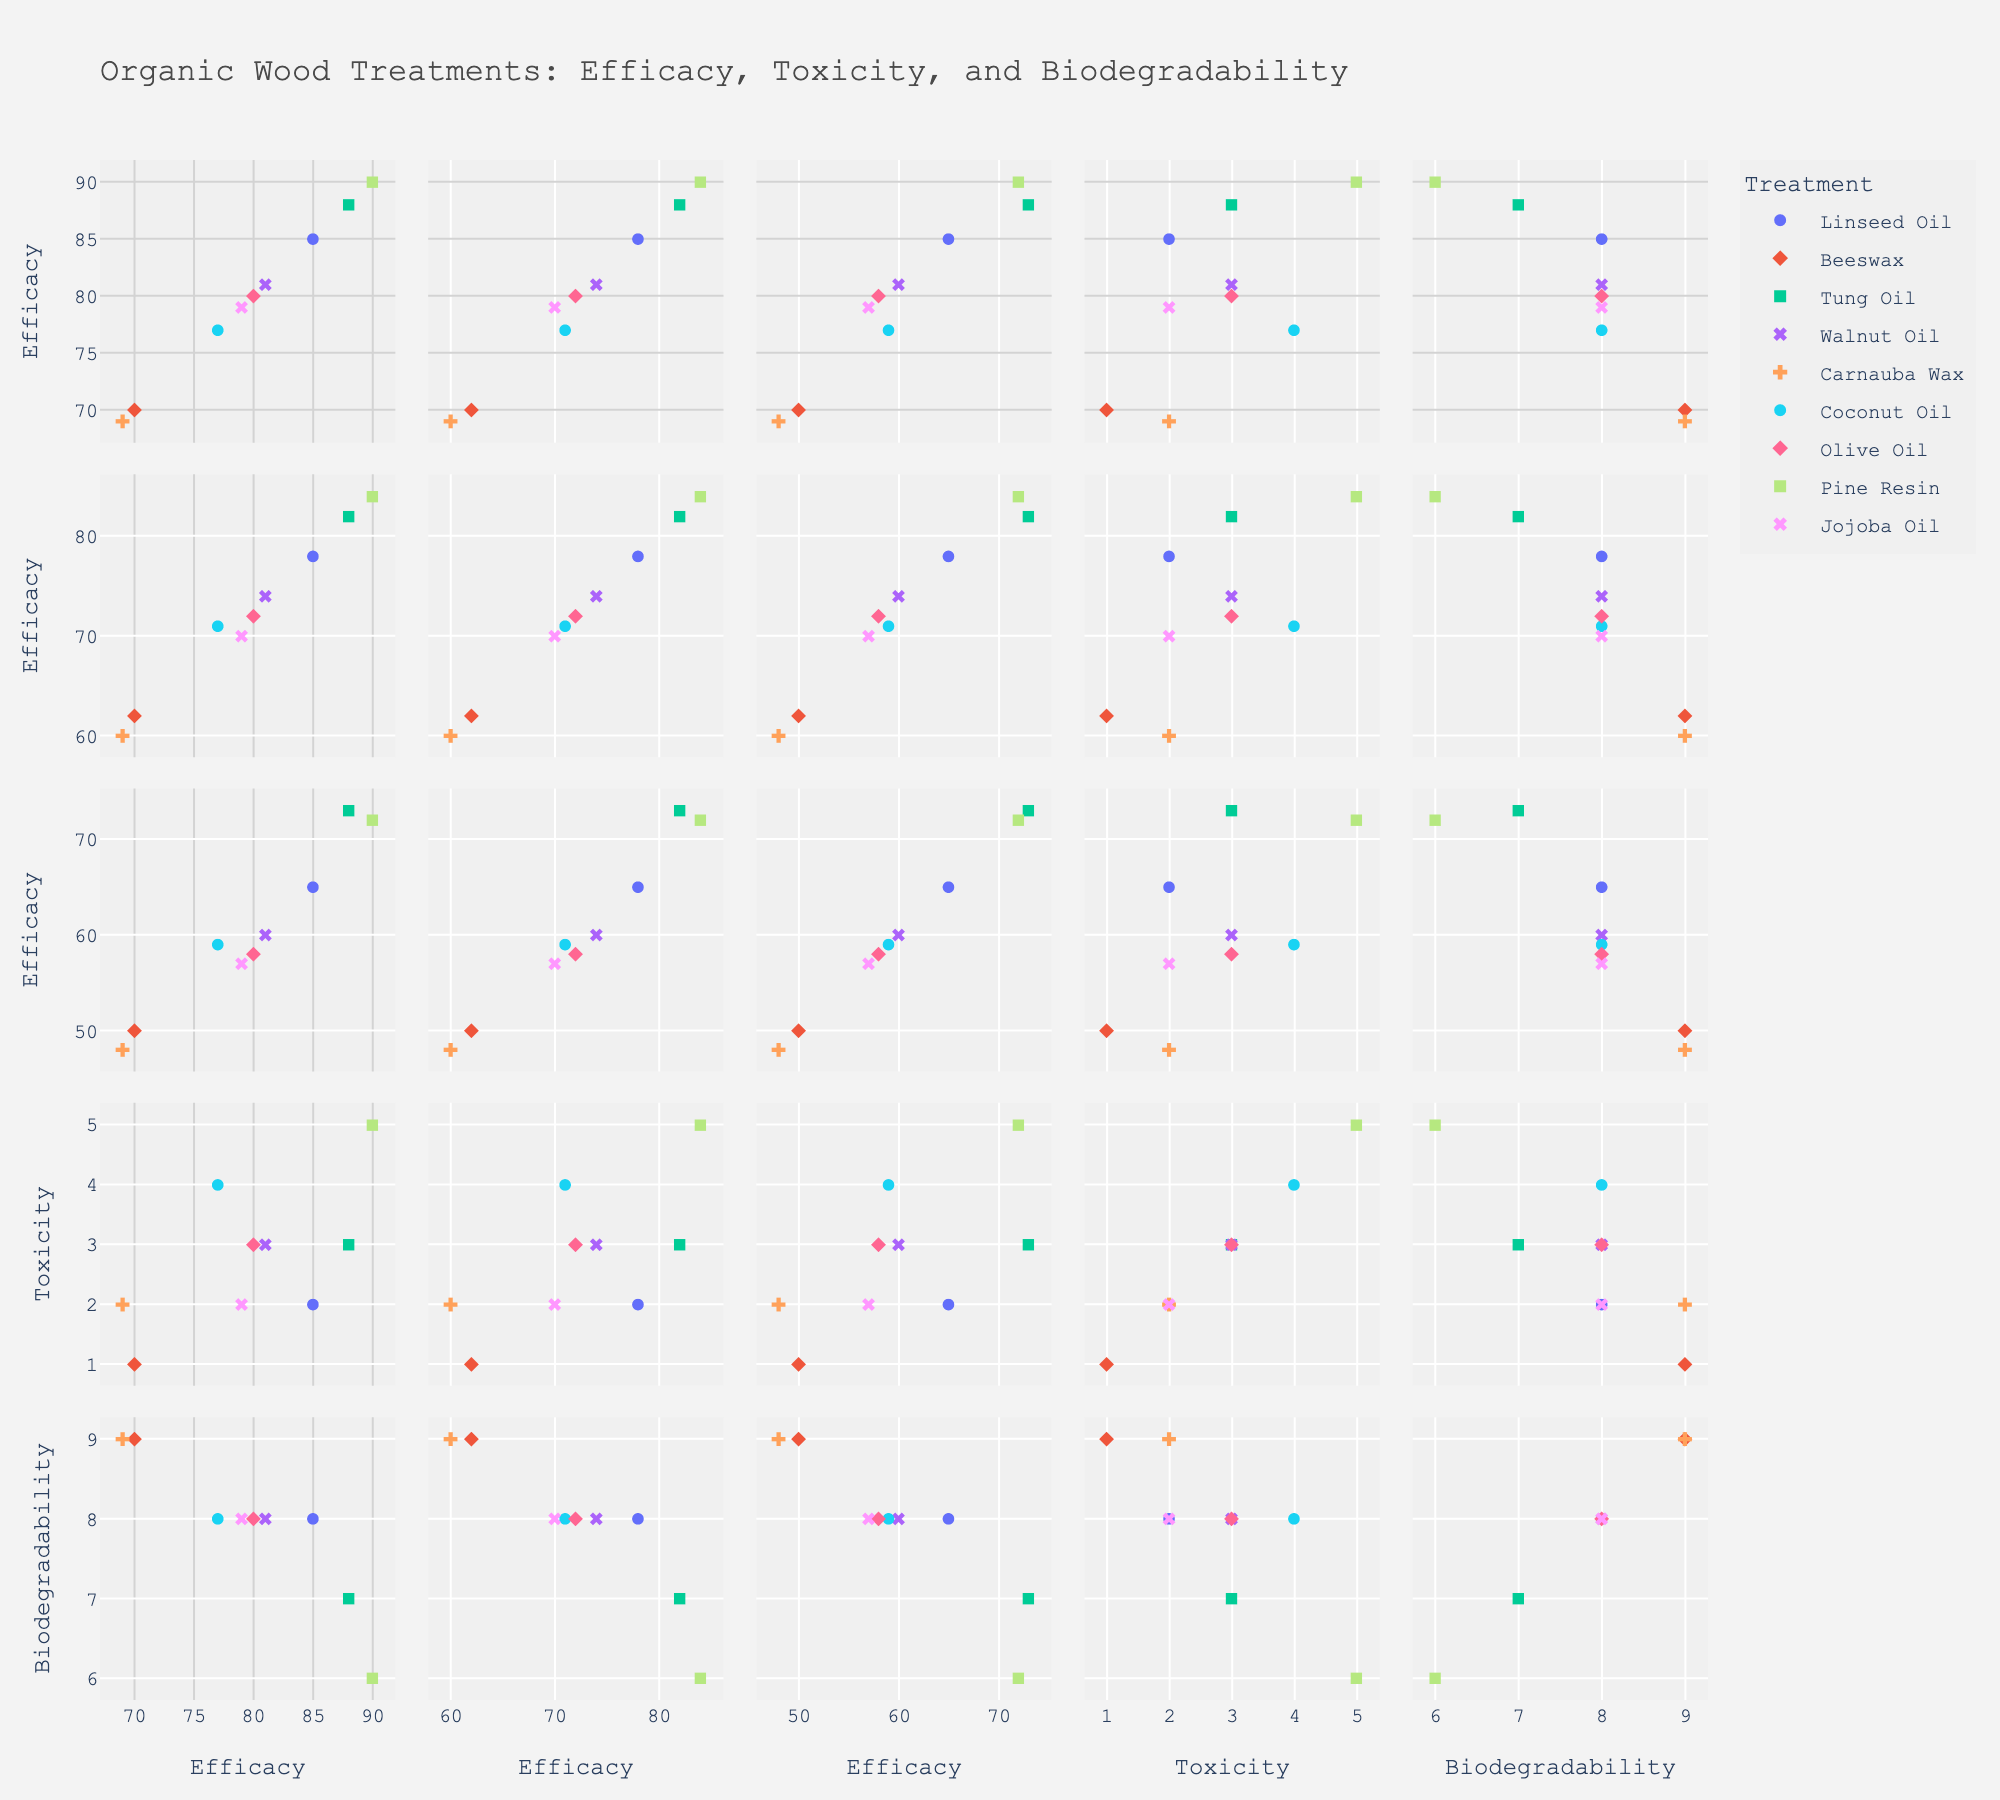What's the title of the figure? The title is usually located at the top of the figure. In this case, it would be indicated as "Organic Wood Treatments: Efficacy, Toxicity, and Biodegradability" according to the setup.
Answer: Organic Wood Treatments: Efficacy, Toxicity, and Biodegradability How can you identify Linseed Oil in the scatter plot matrix? Treatments in the scatter plot matrix can be identified by their color and symbol. Different treatments should have different colors and symbols, which are explained in the legend. Locate Linseed Oil by checking the color and symbol in the legend and then finding the same in the plots.
Answer: By its specific color and symbol in the legend Which treatment has the highest efficacy at 1 month? To find the treatment with the highest efficacy at 1 month, look at the data points on the efficacy at 1 month axis. Compare the values and identify which one is the highest.
Answer: Pine Resin How does the efficacy of Tung Oil change over 12 months? Observe the efficacy values of Tung Oil at 1 month, 6 months, and 12 months across the respective scatter plots. Track Tung Oil's markers to see how the values change over 12 months. The values decrease from 88% to 82% to 73%.
Answer: Decreases from 88% to 73% Which treatments have the highest biodegradability? To identify treatments with the highest biodegradability, find the data points on the biodegradability axis and look for the ones with the highest values. Check the associated treatments using their colors and symbols. Beeswax and Carnauba Wax both have a biodegradability value of 9.
Answer: Beeswax, Carnauba Wax How does toxicity relate to efficacy at 1 month across different treatments? Compare the scatter plot of toxicity vs. efficacy at 1 month. Observe any trends or patterns of data points. Higher efficacy does not necessarily correspond to higher toxicity. Identify any treatments that could indicate such a relationship clearly.
Answer: There is no clear pattern; each treatment varies What is the average efficacy at 12 months for treatments with a toxicity level of 3? Identify treatments with a toxicity of 3 and then note their efficacy at 12 months. These treatments are Tung Oil, Walnut Oil, and Olive Oil, with efficacy values of 73, 60, and 58 respectively. Calculate the average: (73 + 60 + 58) / 3.
Answer: 63.67% Which treatment has the lowest efficacy at 12 months? Look at the efficacy at 12 months axis and seek out the lowest value among the data points. Cross-reference with the legend to identify the corresponding treatment.
Answer: Carnauba Wax Is there a correlation between biodegradability and efficacy at 6 months? Observe the scatter plot correlating biodegradability vs. efficacy at 6 months. Look for any trend, such as increasing or decreasing patterns. In this case, treatments with high biodegradability tend not to have the highest efficacy at 6 months, except for Tung Oil which maintains a relatively good balance.
Answer: Limited correlation How does the biodegradability of Pine Resin compare to Jojoba Oil? Find both Pine Resin and Jojoba Oil in the legend. Then, locate their respective values on the biodegradability axis. Pine Resin has a biodegradability value of 6, while Jojoba Oil has a value of 8. Compare the two values.
Answer: Pine Resin's biodegradability is lower than Jojoba Oil's 